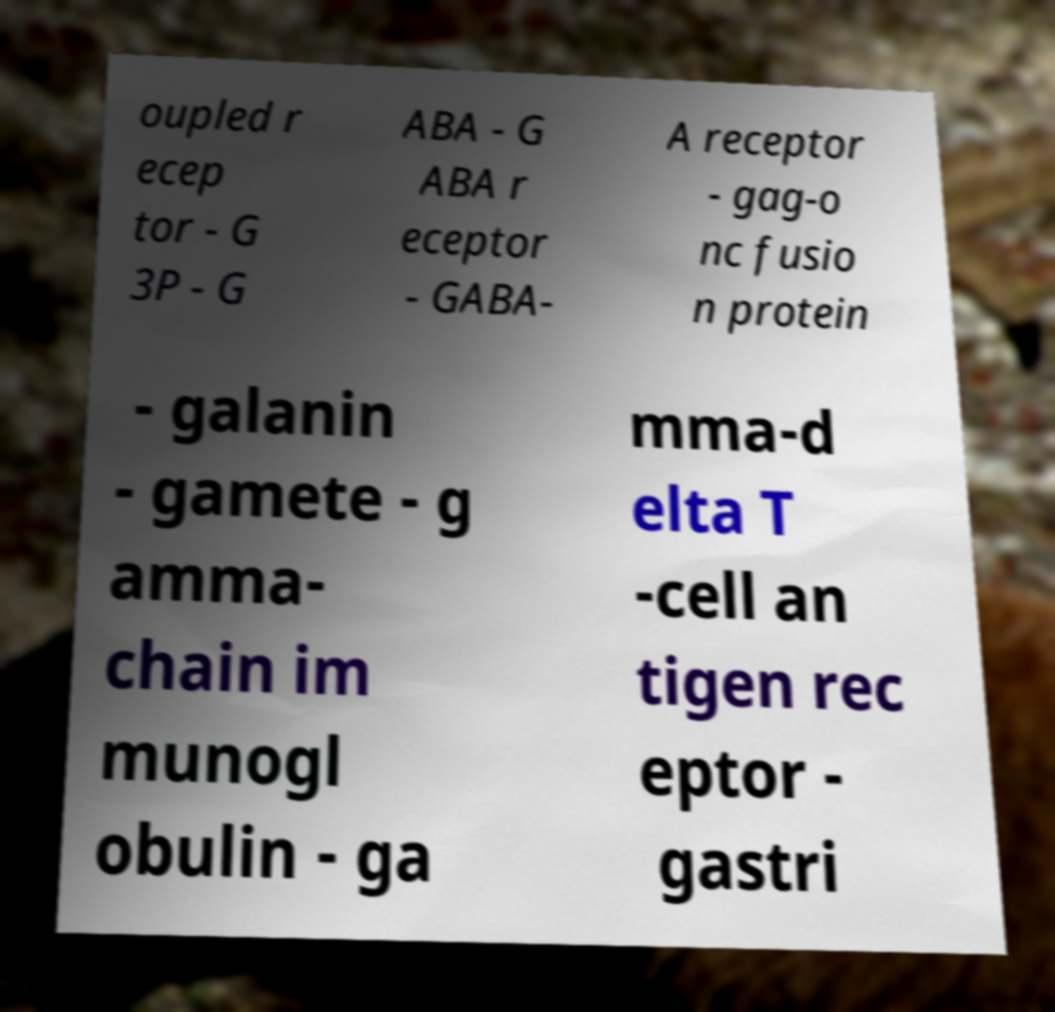Could you extract and type out the text from this image? oupled r ecep tor - G 3P - G ABA - G ABA r eceptor - GABA- A receptor - gag-o nc fusio n protein - galanin - gamete - g amma- chain im munogl obulin - ga mma-d elta T -cell an tigen rec eptor - gastri 